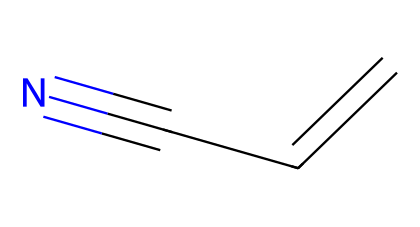What is the name of this chemical? The chemical structure corresponds to acrylonitrile, which is identified by its carbon chain and nitrile functional group.
Answer: acrylonitrile How many carbon atoms are in this molecule? The SMILES representation shows three carbon atoms, as indicated by the letters 'C' in the structure.
Answer: 3 What type of functional group is present in acrylonitrile? The presence of the 'C#N' at the end of the SMILES indicates a nitrile functional group, characterized by the carbon triple-bonded to a nitrogen atom.
Answer: nitrile How many double bonds are in this molecule? The 'C=C' portion of the SMILES indicates that there is one double bond between the first two carbon atoms.
Answer: 1 What is the hybridization of the carbon atoms in the double bond? The carbon atoms involved in the double bond exhibit sp2 hybridization due to the presence of a double bond and associated geometry.
Answer: sp2 What is the primary use of acrylonitrile? Acrylonitrile is primarily used as a precursor in the synthesis of plastics and synthetic rubber, which is an important application in material science.
Answer: plastics and synthetic rubber What is the molecular formula of acrylonitrile? By counting the atoms represented in the SMILES (3 carbons, 3 hydrogens, and 1 nitrogen), the molecular formula can be derived as C3H3N.
Answer: C3H3N 